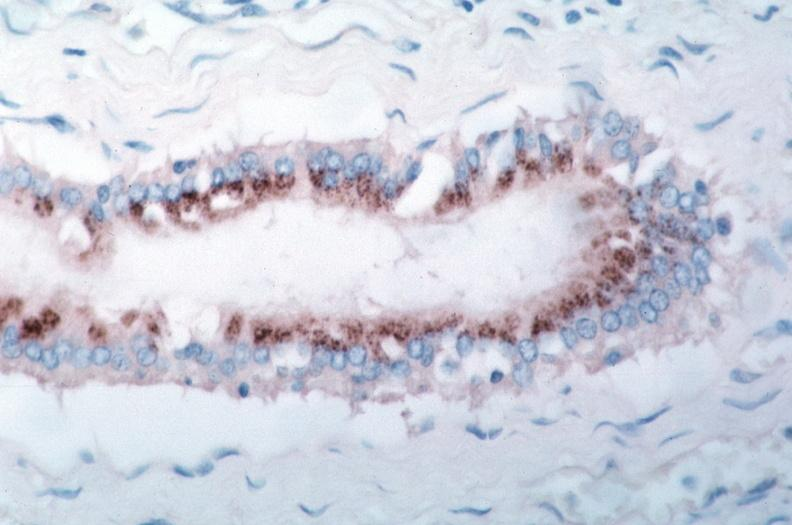where is this from?
Answer the question using a single word or phrase. Vasculature 